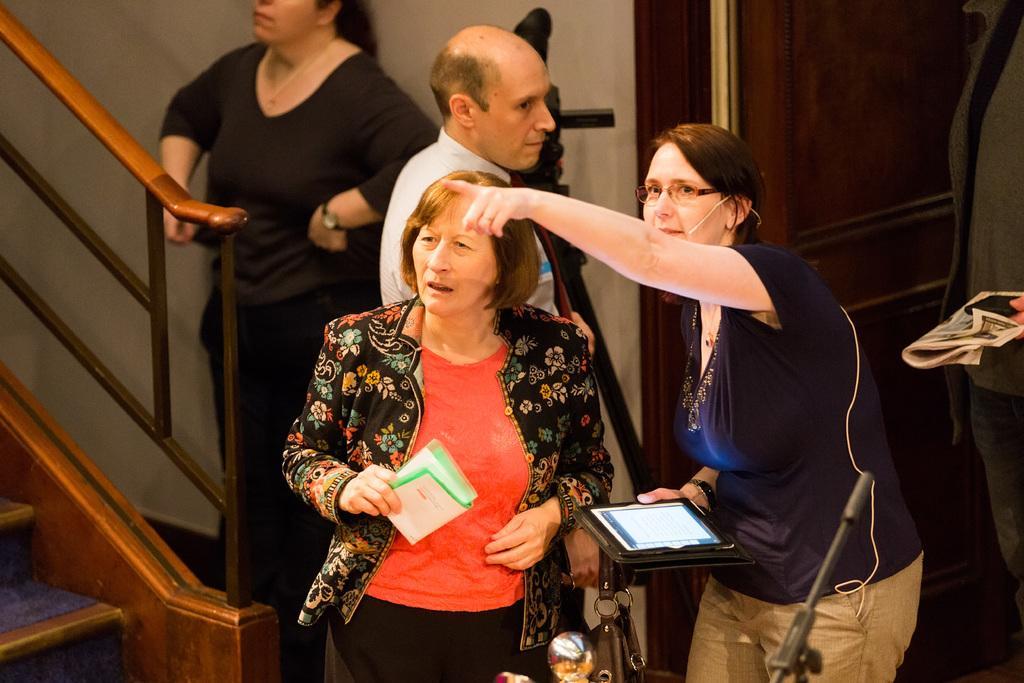Please provide a concise description of this image. The woman in black T-shirt who is wearing spectacles is pointing towards something. She is holding a tablet in her hand. Beside her, we see a woman in red T-shirt and black coat is holding a paper in her hand and she is looking at something. Behind her, we see a man in the white shirt is standing. Beside him, we see a woman in black T-shirt is standing. Behind her, we see a white wall. In front of her, we see a staircase and a stair railing. On the right side, we see a newspaper and a mobile phone. In the background, we see a wall in brown color. 